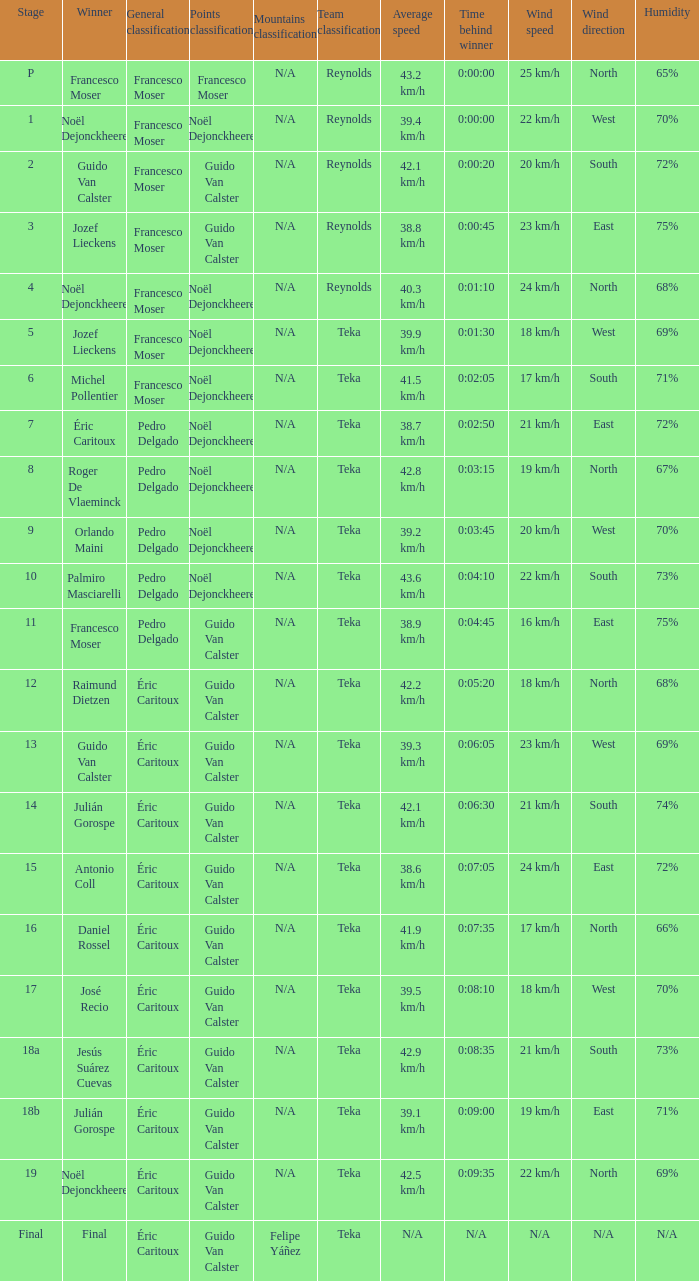Name the points classification of stage 16 Guido Van Calster. 